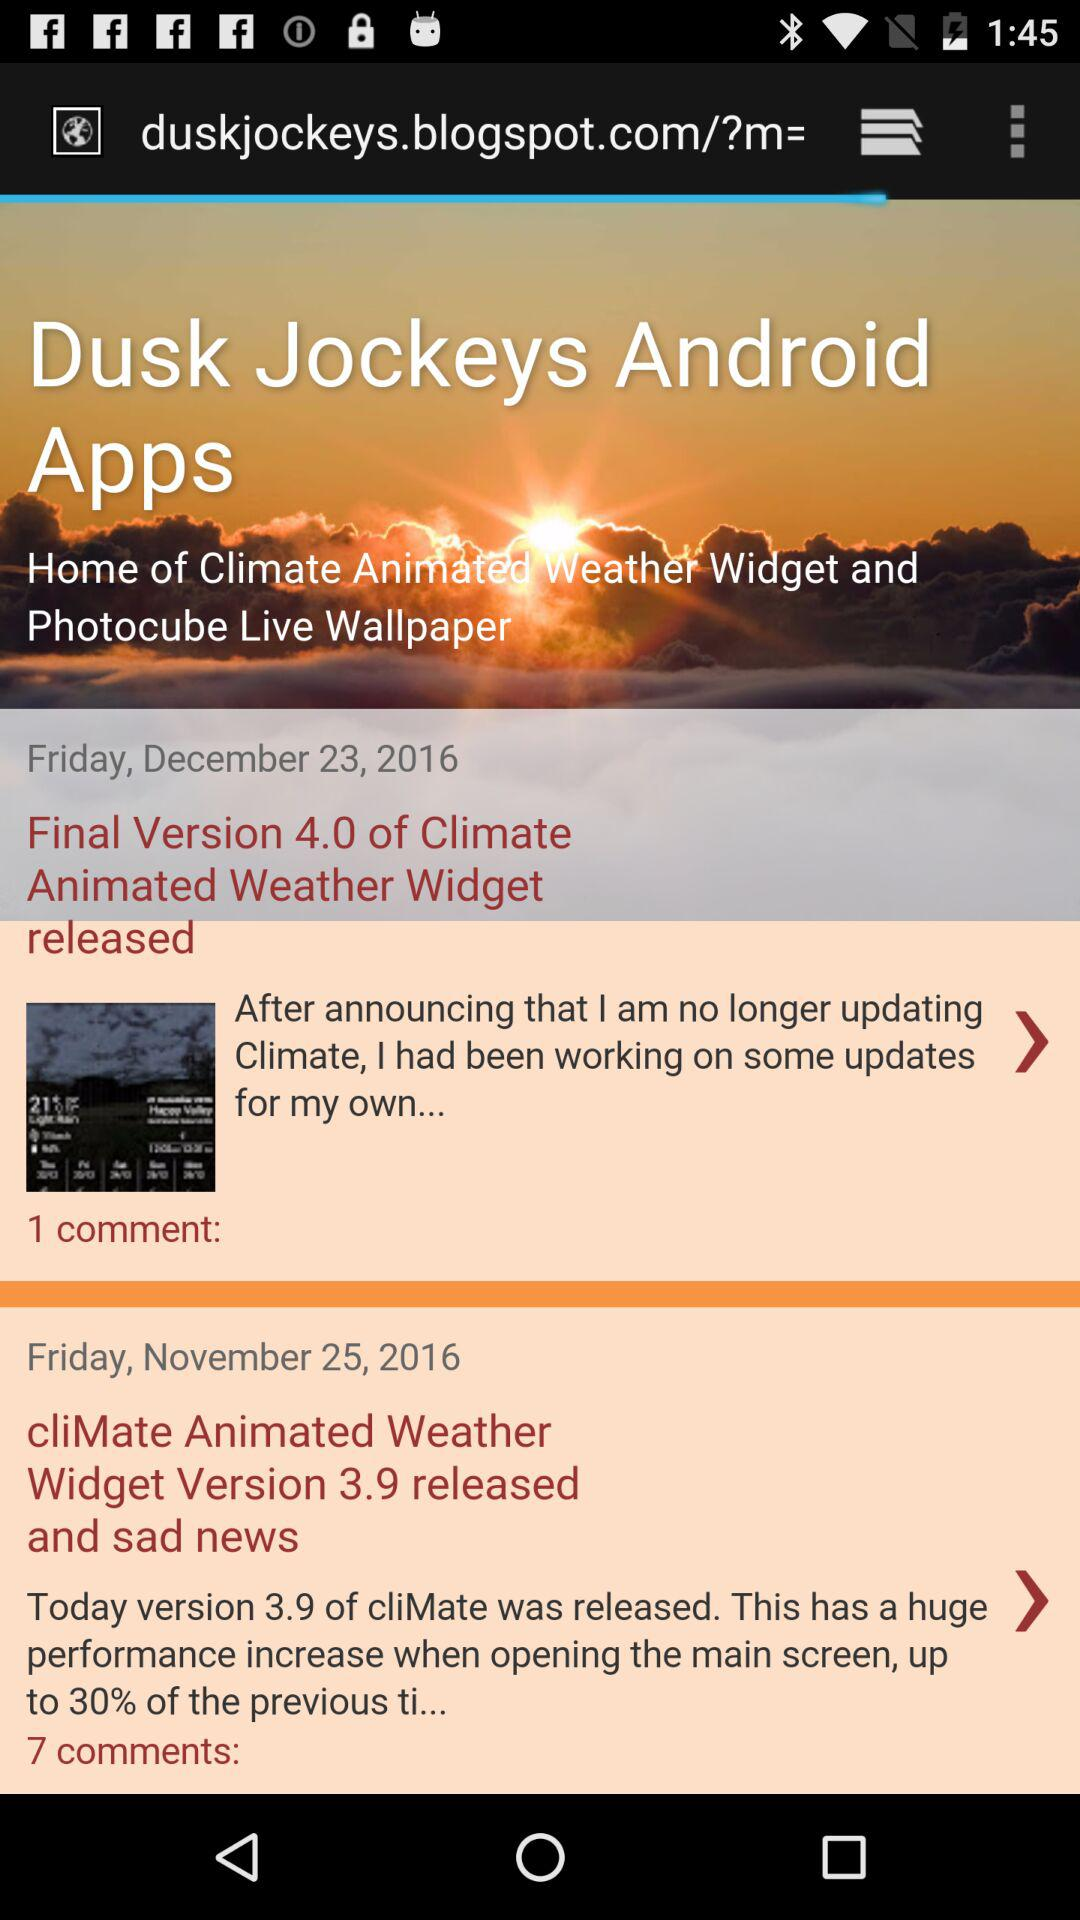How many more comments does the first post have than the second?
Answer the question using a single word or phrase. 6 